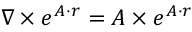<formula> <loc_0><loc_0><loc_500><loc_500>\nabla \times e ^ { A \cdot r } = A \times e ^ { A \cdot r }</formula> 